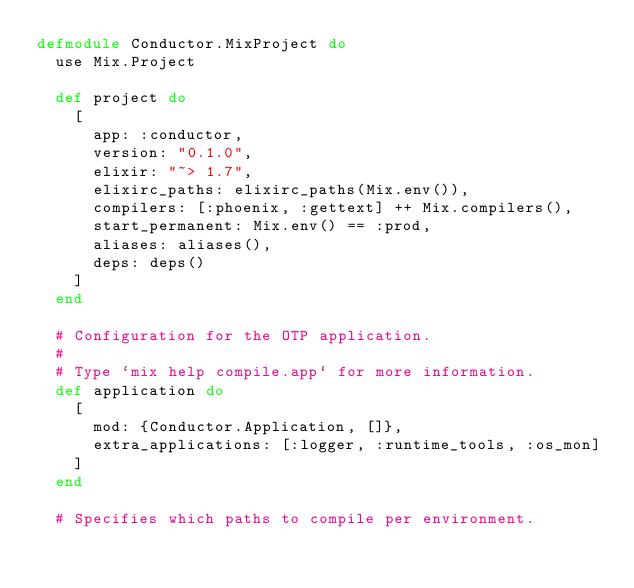<code> <loc_0><loc_0><loc_500><loc_500><_Elixir_>defmodule Conductor.MixProject do
  use Mix.Project

  def project do
    [
      app: :conductor,
      version: "0.1.0",
      elixir: "~> 1.7",
      elixirc_paths: elixirc_paths(Mix.env()),
      compilers: [:phoenix, :gettext] ++ Mix.compilers(),
      start_permanent: Mix.env() == :prod,
      aliases: aliases(),
      deps: deps()
    ]
  end

  # Configuration for the OTP application.
  #
  # Type `mix help compile.app` for more information.
  def application do
    [
      mod: {Conductor.Application, []},
      extra_applications: [:logger, :runtime_tools, :os_mon]
    ]
  end

  # Specifies which paths to compile per environment.</code> 